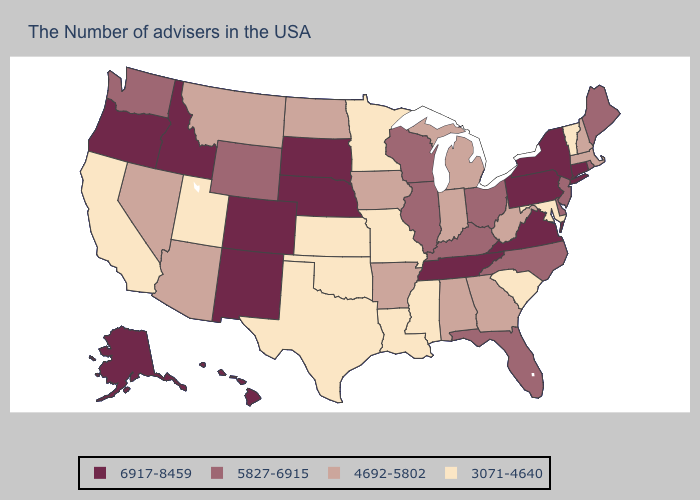What is the value of Washington?
Be succinct. 5827-6915. Does Florida have the highest value in the South?
Be succinct. No. What is the value of Louisiana?
Concise answer only. 3071-4640. Name the states that have a value in the range 6917-8459?
Be succinct. Connecticut, New York, Pennsylvania, Virginia, Tennessee, Nebraska, South Dakota, Colorado, New Mexico, Idaho, Oregon, Alaska, Hawaii. Is the legend a continuous bar?
Answer briefly. No. Does Illinois have the lowest value in the USA?
Short answer required. No. What is the value of Pennsylvania?
Be succinct. 6917-8459. Name the states that have a value in the range 4692-5802?
Short answer required. Massachusetts, New Hampshire, West Virginia, Georgia, Michigan, Indiana, Alabama, Arkansas, Iowa, North Dakota, Montana, Arizona, Nevada. Name the states that have a value in the range 6917-8459?
Keep it brief. Connecticut, New York, Pennsylvania, Virginia, Tennessee, Nebraska, South Dakota, Colorado, New Mexico, Idaho, Oregon, Alaska, Hawaii. Which states hav the highest value in the West?
Be succinct. Colorado, New Mexico, Idaho, Oregon, Alaska, Hawaii. Does Texas have the lowest value in the USA?
Give a very brief answer. Yes. What is the highest value in states that border Texas?
Short answer required. 6917-8459. What is the value of Mississippi?
Be succinct. 3071-4640. Among the states that border California , does Nevada have the lowest value?
Be succinct. Yes. Name the states that have a value in the range 4692-5802?
Write a very short answer. Massachusetts, New Hampshire, West Virginia, Georgia, Michigan, Indiana, Alabama, Arkansas, Iowa, North Dakota, Montana, Arizona, Nevada. 